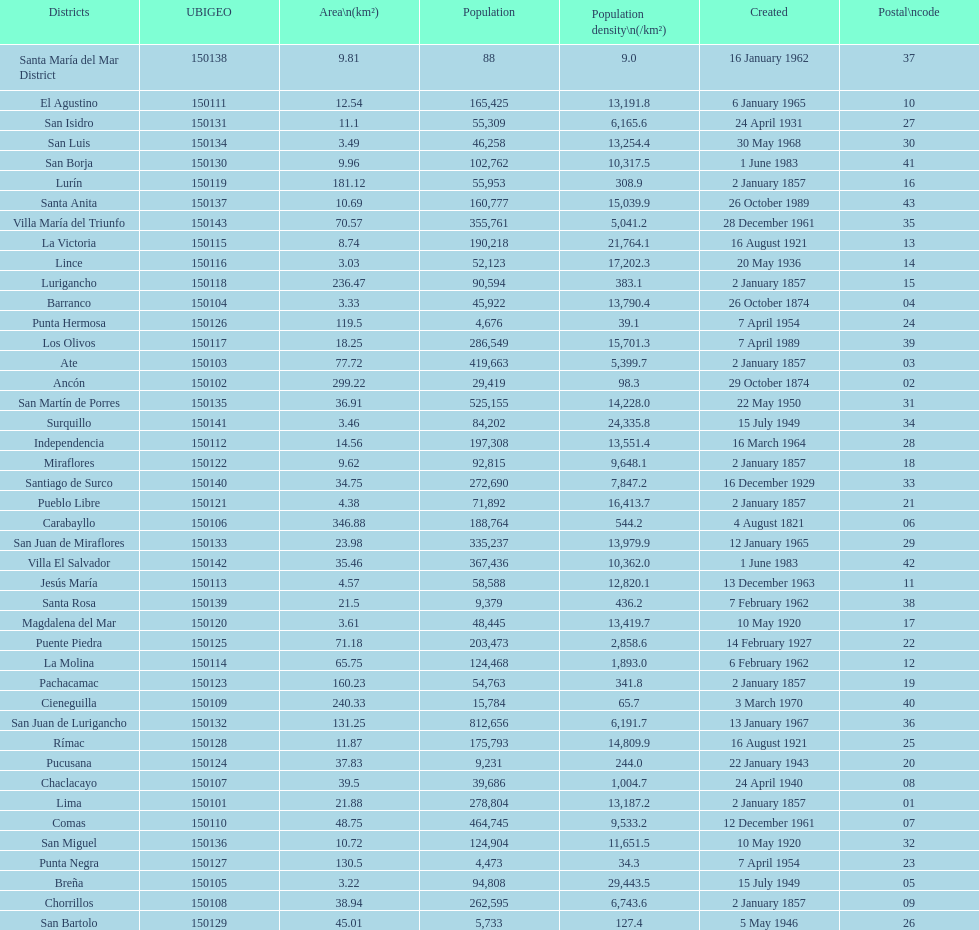What is the total number of districts created in the 1900's? 32. 